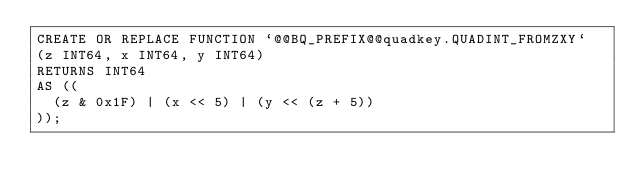<code> <loc_0><loc_0><loc_500><loc_500><_SQL_>CREATE OR REPLACE FUNCTION `@@BQ_PREFIX@@quadkey.QUADINT_FROMZXY`
(z INT64, x INT64, y INT64)
RETURNS INT64
AS ((
  (z & 0x1F) | (x << 5) | (y << (z + 5))
));</code> 